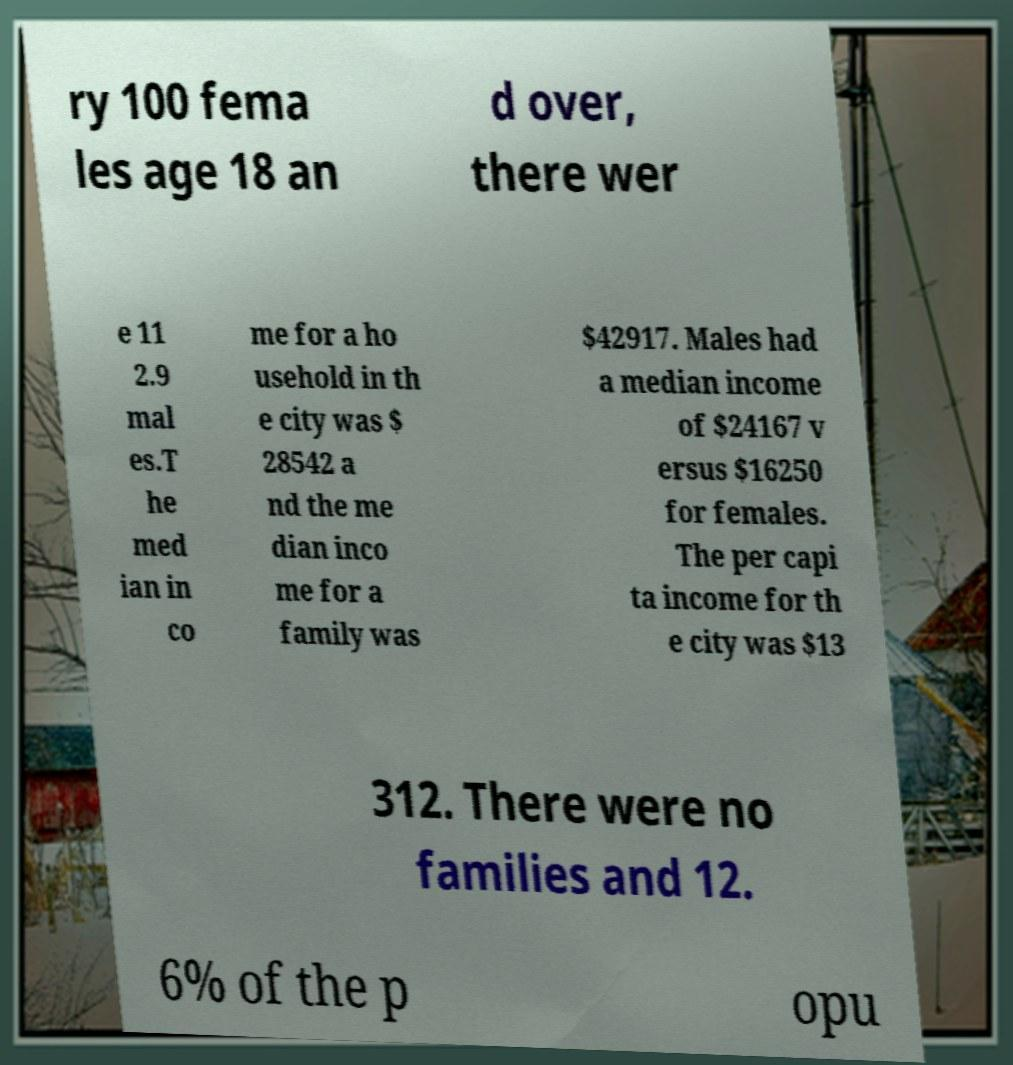Can you read and provide the text displayed in the image?This photo seems to have some interesting text. Can you extract and type it out for me? ry 100 fema les age 18 an d over, there wer e 11 2.9 mal es.T he med ian in co me for a ho usehold in th e city was $ 28542 a nd the me dian inco me for a family was $42917. Males had a median income of $24167 v ersus $16250 for females. The per capi ta income for th e city was $13 312. There were no families and 12. 6% of the p opu 